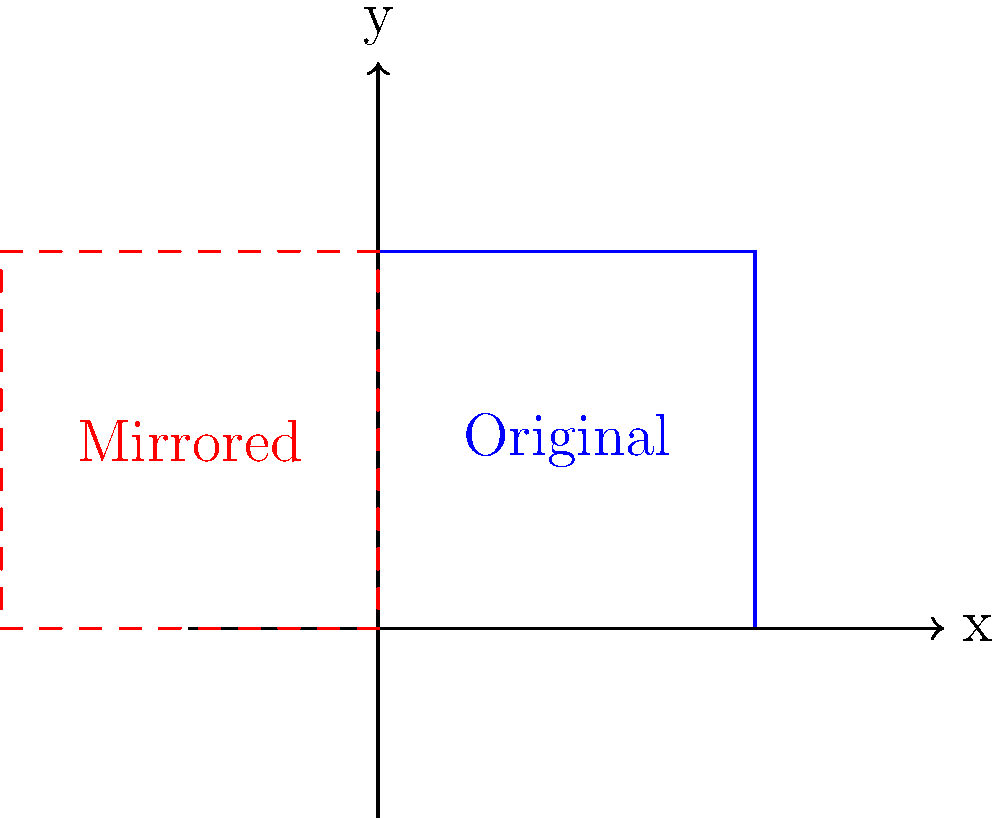In the context of data mirroring for digital repositories, a database symbol is reflected across the y-axis. If the original database symbol has coordinates A(0,0), B(2,0), C(2,2), and D(0,2), what are the coordinates of point B' in the mirrored image? To solve this problem, we need to understand the concept of reflection across the y-axis in transformational geometry. When reflecting a point across the y-axis:

1. The y-coordinate remains unchanged.
2. The x-coordinate changes sign (positive becomes negative and vice versa).

For point B in the original database symbol:
1. Original coordinates of B: (2,0)
2. To reflect across the y-axis:
   - Keep y-coordinate the same: 0
   - Change sign of x-coordinate: 2 becomes -2

Therefore, the coordinates of B' in the mirrored image are (-2,0).

This reflection represents data mirroring in digital repositories, where data is replicated to create an exact copy, often used for backup or load balancing purposes.
Answer: (-2,0) 